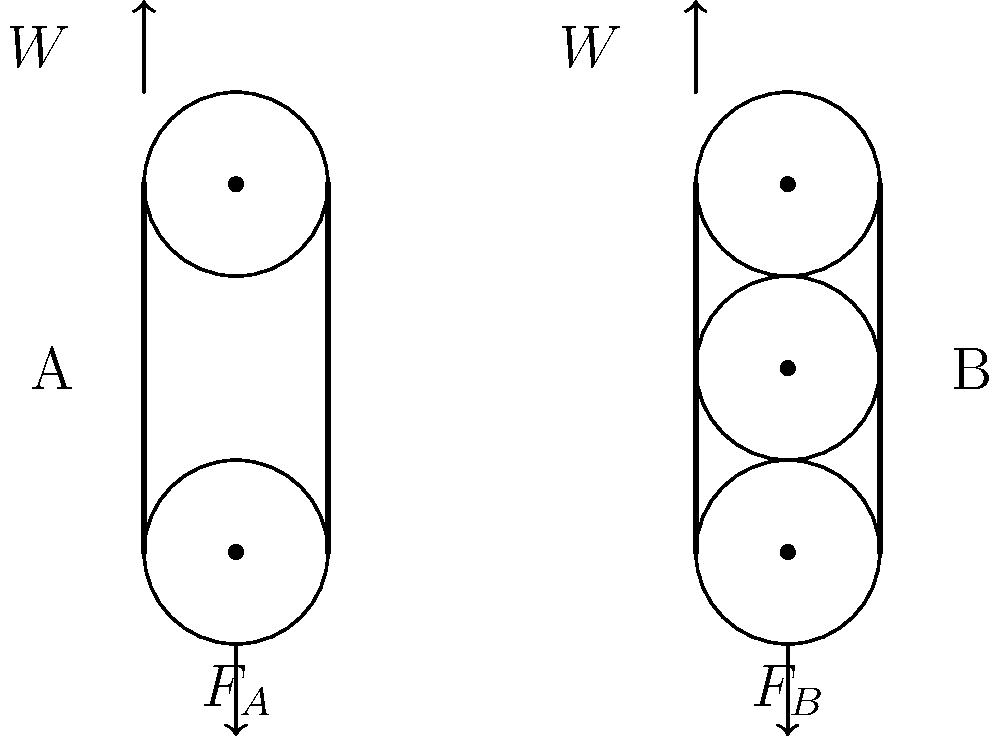As you prepare for a Hellboy-themed art exhibition, you encounter a challenge in hanging heavy artwork. Two pulley systems (A and B) are available, as shown in the schematic. Both systems are designed to lift the same weight $W$. If $F_A$ and $F_B$ represent the forces required to lift the weight using systems A and B respectively, what is the ratio of $F_A$ to $F_B$? Let's analyze each pulley system step-by-step:

1. System A:
   - This is a single movable pulley system.
   - The weight $W$ is distributed equally between two ropes.
   - The force required: $F_A = \frac{W}{2}$

2. System B:
   - This is a compound pulley system with two movable pulleys.
   - Each movable pulley reduces the force by half.
   - The force required: $F_B = \frac{W}{4}$

3. To find the ratio $\frac{F_A}{F_B}$:
   $\frac{F_A}{F_B} = \frac{\frac{W}{2}}{\frac{W}{4}} = \frac{W}{2} \cdot \frac{4}{W} = 2$

Therefore, the ratio of $F_A$ to $F_B$ is 2:1, meaning system A requires twice the force of system B to lift the same weight.
Answer: 2:1 